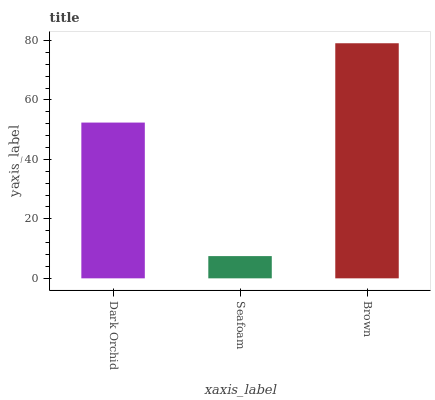Is Seafoam the minimum?
Answer yes or no. Yes. Is Brown the maximum?
Answer yes or no. Yes. Is Brown the minimum?
Answer yes or no. No. Is Seafoam the maximum?
Answer yes or no. No. Is Brown greater than Seafoam?
Answer yes or no. Yes. Is Seafoam less than Brown?
Answer yes or no. Yes. Is Seafoam greater than Brown?
Answer yes or no. No. Is Brown less than Seafoam?
Answer yes or no. No. Is Dark Orchid the high median?
Answer yes or no. Yes. Is Dark Orchid the low median?
Answer yes or no. Yes. Is Brown the high median?
Answer yes or no. No. Is Seafoam the low median?
Answer yes or no. No. 